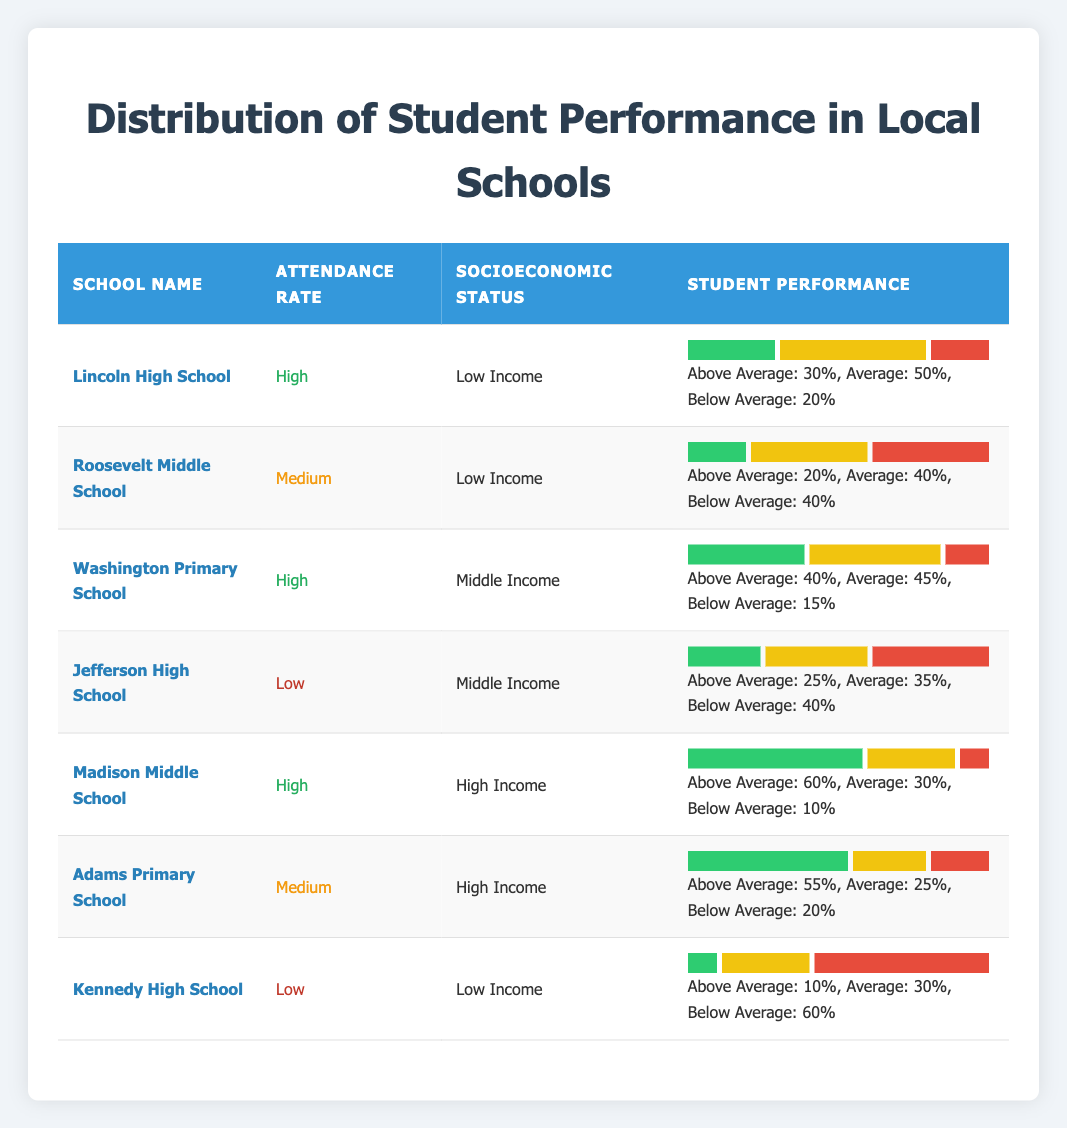What is the attendance rate of Lincoln High School? According to the table, Lincoln High School has an attendance rate described as "High."
Answer: High How many students at Roosevelt Middle School performed Below Average? The table indicates that 40 students at Roosevelt Middle School scored Below Average.
Answer: 40 Which school has the highest percentage of Above Average students? By comparing the percentages of Above Average performance from each school, Madison Middle School has the highest at 60%.
Answer: Madison Middle School Is it true that Kennedy High School has more Below Average students than Above Average students? Kennedy High School has 60 students Below Average and only 10 Above Average, confirming that there are more Below Average students than Above Average.
Answer: Yes What is the average percentage of students performing Above Average across all schools? To find the average, we sum the Above Average percentages (30 + 20 + 40 + 25 + 60 + 55 + 10) = 270. With 7 data points, the average is 270/7 = approximately 38.57.
Answer: 38.57 Which socioeconomic status grouping has the highest percentage of Above Average students? Analyzing the data, High Income schools (Madison Middle School and Adams Primary School) have an average Above Average performance of (60 + 55) / 2 = 57.5%, higher than Low Income and Middle Income groups.
Answer: High Income How many students at Washington Primary School are Average performers? The table shows that 45 students at Washington Primary School fall under the Average performance category.
Answer: 45 Which school has the lowest percentage of students performing Above Average and what is that percentage? Kennedy High School has the lowest percentage of Above Average students at 10%.
Answer: 10 Are there any schools with a Medium attendance rate that have Below Average student performance above 20%? Roosevelt Middle School and Adams Primary School both have a Medium attendance rate, with 40% and 20% Below Average performance, respectively. Roosevelt has a Below Average percentage above 20%.
Answer: Yes What percentage of students in Middle Income schools performed Above Average? The Above Average percentages for Middle Income schools (Washington Primary School and Jefferson High School) are 40% and 25%, respectively. The average is (40 + 25) / 2 = 32.5%.
Answer: 32.5% 